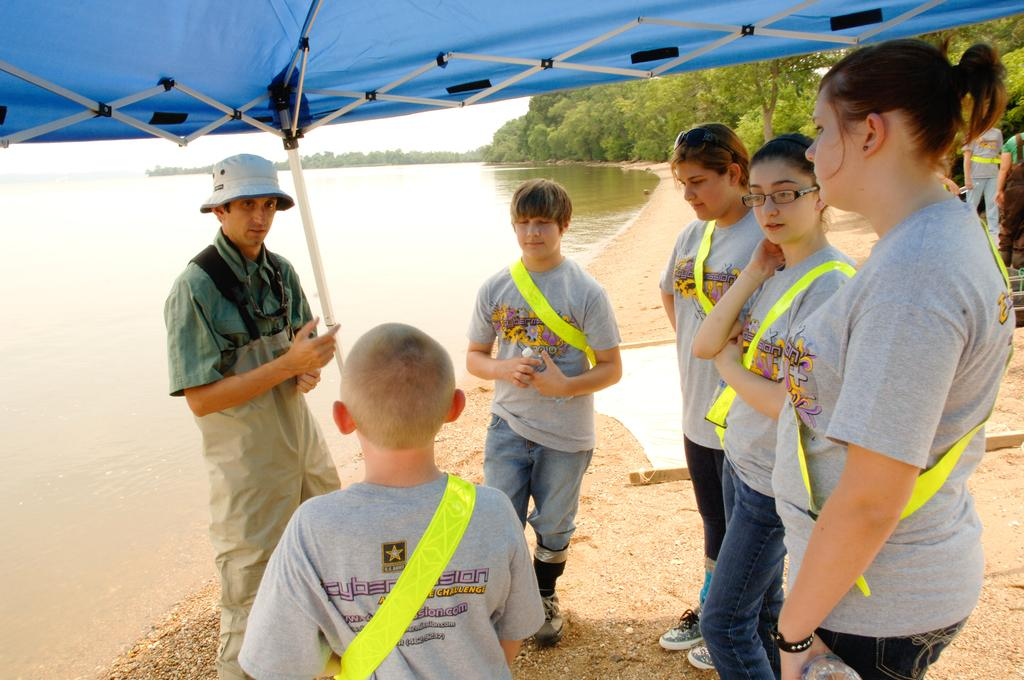What is happening in the image? There are people standing in the image. What can be seen on the left side of the image? There is water on the left side of the image. What is visible in the background of the image? There are trees in the background of the image. What structure can be seen at the top of the image? There appears to be a tent at the top of the image. What type of rice is being transported by the balloon in the image? There is no balloon or rice present in the image. 